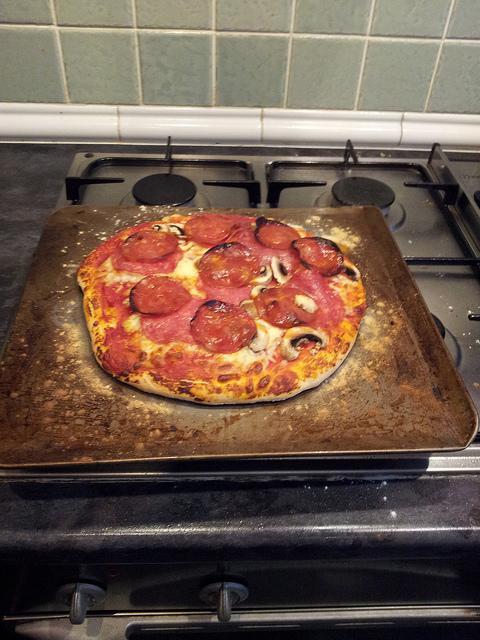How many pizzas are on the stove?
Give a very brief answer. 1. How many faces of the clock can you see completely?
Give a very brief answer. 0. 